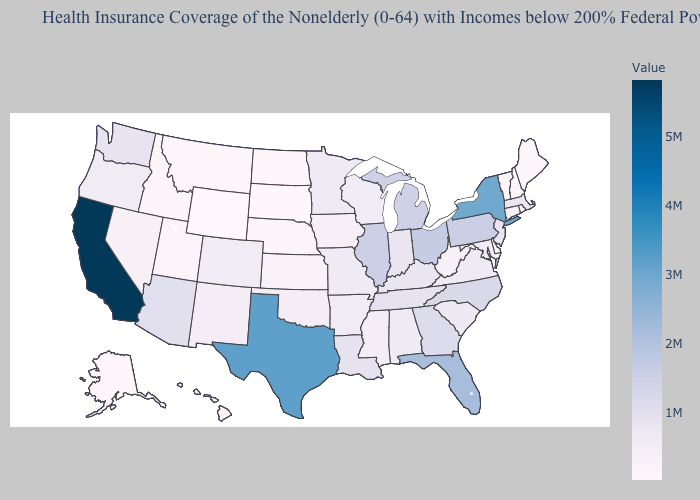Does Utah have the lowest value in the West?
Write a very short answer. No. Which states hav the highest value in the West?
Quick response, please. California. Among the states that border New Mexico , does Oklahoma have the highest value?
Keep it brief. No. Which states have the lowest value in the USA?
Be succinct. Wyoming. Does Wyoming have the lowest value in the USA?
Answer briefly. Yes. Does Vermont have the lowest value in the Northeast?
Concise answer only. Yes. Among the states that border Texas , which have the lowest value?
Write a very short answer. Oklahoma. Which states have the lowest value in the Northeast?
Give a very brief answer. Vermont. 